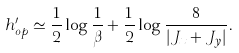<formula> <loc_0><loc_0><loc_500><loc_500>h ^ { \prime } _ { o p } \simeq \frac { 1 } { 2 } \log \frac { 1 } { \beta } + \frac { 1 } { 2 } \log \frac { 8 } { | J _ { x } + J _ { y } | } .</formula> 